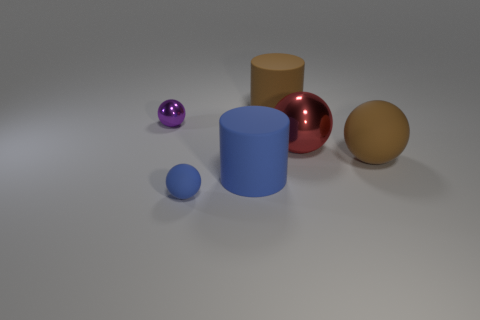What is the shape of the brown matte thing that is behind the small object to the left of the small object that is in front of the tiny shiny thing?
Give a very brief answer. Cylinder. Is the number of balls that are right of the big blue object the same as the number of brown objects?
Provide a short and direct response. Yes. Is the blue rubber ball the same size as the red object?
Keep it short and to the point. No. What number of metallic objects are small cyan cubes or brown things?
Give a very brief answer. 0. What is the material of the red ball that is the same size as the blue cylinder?
Give a very brief answer. Metal. What number of other things are the same material as the purple ball?
Make the answer very short. 1. Is the number of tiny matte spheres that are to the right of the big rubber sphere less than the number of tiny blue rubber objects?
Give a very brief answer. Yes. Is the tiny rubber thing the same shape as the large metallic thing?
Offer a terse response. Yes. There is a cylinder in front of the small ball that is behind the brown rubber thing in front of the purple sphere; what size is it?
Provide a short and direct response. Large. What is the material of the other large object that is the same shape as the red metallic thing?
Provide a short and direct response. Rubber. 